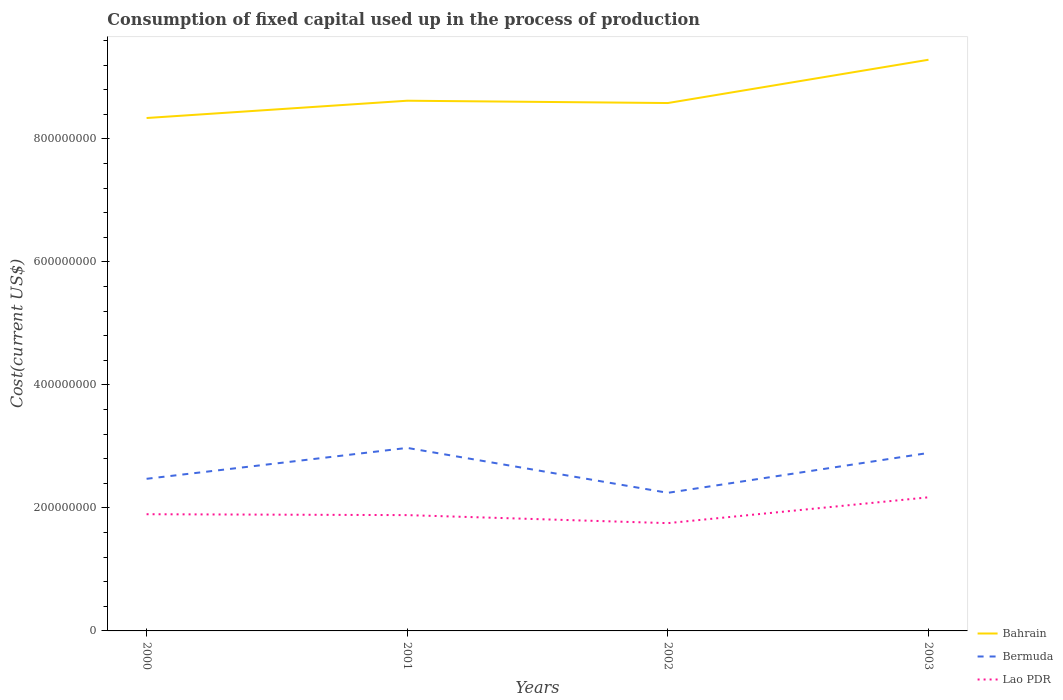Does the line corresponding to Bermuda intersect with the line corresponding to Bahrain?
Your answer should be very brief. No. Across all years, what is the maximum amount consumed in the process of production in Lao PDR?
Your response must be concise. 1.75e+08. In which year was the amount consumed in the process of production in Bahrain maximum?
Offer a terse response. 2000. What is the total amount consumed in the process of production in Bahrain in the graph?
Offer a terse response. -2.81e+07. What is the difference between the highest and the second highest amount consumed in the process of production in Bermuda?
Your answer should be compact. 7.31e+07. What is the difference between the highest and the lowest amount consumed in the process of production in Lao PDR?
Give a very brief answer. 1. How many legend labels are there?
Your answer should be very brief. 3. What is the title of the graph?
Offer a terse response. Consumption of fixed capital used up in the process of production. Does "Fiji" appear as one of the legend labels in the graph?
Make the answer very short. No. What is the label or title of the Y-axis?
Ensure brevity in your answer.  Cost(current US$). What is the Cost(current US$) in Bahrain in 2000?
Provide a succinct answer. 8.34e+08. What is the Cost(current US$) in Bermuda in 2000?
Your answer should be very brief. 2.47e+08. What is the Cost(current US$) of Lao PDR in 2000?
Offer a terse response. 1.90e+08. What is the Cost(current US$) in Bahrain in 2001?
Offer a very short reply. 8.62e+08. What is the Cost(current US$) of Bermuda in 2001?
Your answer should be compact. 2.98e+08. What is the Cost(current US$) of Lao PDR in 2001?
Ensure brevity in your answer.  1.88e+08. What is the Cost(current US$) of Bahrain in 2002?
Offer a terse response. 8.58e+08. What is the Cost(current US$) in Bermuda in 2002?
Your response must be concise. 2.25e+08. What is the Cost(current US$) of Lao PDR in 2002?
Ensure brevity in your answer.  1.75e+08. What is the Cost(current US$) in Bahrain in 2003?
Offer a terse response. 9.29e+08. What is the Cost(current US$) in Bermuda in 2003?
Provide a short and direct response. 2.89e+08. What is the Cost(current US$) in Lao PDR in 2003?
Provide a short and direct response. 2.17e+08. Across all years, what is the maximum Cost(current US$) in Bahrain?
Give a very brief answer. 9.29e+08. Across all years, what is the maximum Cost(current US$) of Bermuda?
Offer a terse response. 2.98e+08. Across all years, what is the maximum Cost(current US$) in Lao PDR?
Provide a succinct answer. 2.17e+08. Across all years, what is the minimum Cost(current US$) of Bahrain?
Ensure brevity in your answer.  8.34e+08. Across all years, what is the minimum Cost(current US$) in Bermuda?
Provide a short and direct response. 2.25e+08. Across all years, what is the minimum Cost(current US$) of Lao PDR?
Provide a short and direct response. 1.75e+08. What is the total Cost(current US$) of Bahrain in the graph?
Make the answer very short. 3.48e+09. What is the total Cost(current US$) of Bermuda in the graph?
Your answer should be compact. 1.06e+09. What is the total Cost(current US$) in Lao PDR in the graph?
Keep it short and to the point. 7.71e+08. What is the difference between the Cost(current US$) in Bahrain in 2000 and that in 2001?
Provide a succinct answer. -2.81e+07. What is the difference between the Cost(current US$) in Bermuda in 2000 and that in 2001?
Provide a succinct answer. -5.02e+07. What is the difference between the Cost(current US$) in Lao PDR in 2000 and that in 2001?
Make the answer very short. 1.45e+06. What is the difference between the Cost(current US$) in Bahrain in 2000 and that in 2002?
Offer a terse response. -2.44e+07. What is the difference between the Cost(current US$) in Bermuda in 2000 and that in 2002?
Keep it short and to the point. 2.28e+07. What is the difference between the Cost(current US$) in Lao PDR in 2000 and that in 2002?
Provide a short and direct response. 1.45e+07. What is the difference between the Cost(current US$) in Bahrain in 2000 and that in 2003?
Ensure brevity in your answer.  -9.48e+07. What is the difference between the Cost(current US$) in Bermuda in 2000 and that in 2003?
Provide a short and direct response. -4.21e+07. What is the difference between the Cost(current US$) of Lao PDR in 2000 and that in 2003?
Your response must be concise. -2.75e+07. What is the difference between the Cost(current US$) in Bahrain in 2001 and that in 2002?
Provide a succinct answer. 3.76e+06. What is the difference between the Cost(current US$) of Bermuda in 2001 and that in 2002?
Ensure brevity in your answer.  7.31e+07. What is the difference between the Cost(current US$) in Lao PDR in 2001 and that in 2002?
Your answer should be very brief. 1.30e+07. What is the difference between the Cost(current US$) in Bahrain in 2001 and that in 2003?
Provide a short and direct response. -6.66e+07. What is the difference between the Cost(current US$) of Bermuda in 2001 and that in 2003?
Make the answer very short. 8.18e+06. What is the difference between the Cost(current US$) of Lao PDR in 2001 and that in 2003?
Your response must be concise. -2.90e+07. What is the difference between the Cost(current US$) in Bahrain in 2002 and that in 2003?
Provide a short and direct response. -7.04e+07. What is the difference between the Cost(current US$) of Bermuda in 2002 and that in 2003?
Provide a short and direct response. -6.49e+07. What is the difference between the Cost(current US$) of Lao PDR in 2002 and that in 2003?
Provide a succinct answer. -4.20e+07. What is the difference between the Cost(current US$) of Bahrain in 2000 and the Cost(current US$) of Bermuda in 2001?
Offer a terse response. 5.36e+08. What is the difference between the Cost(current US$) of Bahrain in 2000 and the Cost(current US$) of Lao PDR in 2001?
Give a very brief answer. 6.46e+08. What is the difference between the Cost(current US$) in Bermuda in 2000 and the Cost(current US$) in Lao PDR in 2001?
Provide a succinct answer. 5.91e+07. What is the difference between the Cost(current US$) of Bahrain in 2000 and the Cost(current US$) of Bermuda in 2002?
Ensure brevity in your answer.  6.10e+08. What is the difference between the Cost(current US$) in Bahrain in 2000 and the Cost(current US$) in Lao PDR in 2002?
Provide a succinct answer. 6.59e+08. What is the difference between the Cost(current US$) of Bermuda in 2000 and the Cost(current US$) of Lao PDR in 2002?
Keep it short and to the point. 7.21e+07. What is the difference between the Cost(current US$) of Bahrain in 2000 and the Cost(current US$) of Bermuda in 2003?
Keep it short and to the point. 5.45e+08. What is the difference between the Cost(current US$) of Bahrain in 2000 and the Cost(current US$) of Lao PDR in 2003?
Ensure brevity in your answer.  6.17e+08. What is the difference between the Cost(current US$) of Bermuda in 2000 and the Cost(current US$) of Lao PDR in 2003?
Keep it short and to the point. 3.01e+07. What is the difference between the Cost(current US$) of Bahrain in 2001 and the Cost(current US$) of Bermuda in 2002?
Provide a short and direct response. 6.38e+08. What is the difference between the Cost(current US$) in Bahrain in 2001 and the Cost(current US$) in Lao PDR in 2002?
Provide a short and direct response. 6.87e+08. What is the difference between the Cost(current US$) of Bermuda in 2001 and the Cost(current US$) of Lao PDR in 2002?
Make the answer very short. 1.22e+08. What is the difference between the Cost(current US$) of Bahrain in 2001 and the Cost(current US$) of Bermuda in 2003?
Offer a very short reply. 5.73e+08. What is the difference between the Cost(current US$) in Bahrain in 2001 and the Cost(current US$) in Lao PDR in 2003?
Your response must be concise. 6.45e+08. What is the difference between the Cost(current US$) in Bermuda in 2001 and the Cost(current US$) in Lao PDR in 2003?
Your answer should be very brief. 8.03e+07. What is the difference between the Cost(current US$) of Bahrain in 2002 and the Cost(current US$) of Bermuda in 2003?
Make the answer very short. 5.69e+08. What is the difference between the Cost(current US$) in Bahrain in 2002 and the Cost(current US$) in Lao PDR in 2003?
Provide a short and direct response. 6.41e+08. What is the difference between the Cost(current US$) in Bermuda in 2002 and the Cost(current US$) in Lao PDR in 2003?
Make the answer very short. 7.29e+06. What is the average Cost(current US$) in Bahrain per year?
Your answer should be compact. 8.71e+08. What is the average Cost(current US$) of Bermuda per year?
Make the answer very short. 2.65e+08. What is the average Cost(current US$) of Lao PDR per year?
Make the answer very short. 1.93e+08. In the year 2000, what is the difference between the Cost(current US$) of Bahrain and Cost(current US$) of Bermuda?
Offer a terse response. 5.87e+08. In the year 2000, what is the difference between the Cost(current US$) of Bahrain and Cost(current US$) of Lao PDR?
Offer a terse response. 6.44e+08. In the year 2000, what is the difference between the Cost(current US$) in Bermuda and Cost(current US$) in Lao PDR?
Provide a succinct answer. 5.76e+07. In the year 2001, what is the difference between the Cost(current US$) of Bahrain and Cost(current US$) of Bermuda?
Your response must be concise. 5.65e+08. In the year 2001, what is the difference between the Cost(current US$) in Bahrain and Cost(current US$) in Lao PDR?
Make the answer very short. 6.74e+08. In the year 2001, what is the difference between the Cost(current US$) of Bermuda and Cost(current US$) of Lao PDR?
Keep it short and to the point. 1.09e+08. In the year 2002, what is the difference between the Cost(current US$) in Bahrain and Cost(current US$) in Bermuda?
Keep it short and to the point. 6.34e+08. In the year 2002, what is the difference between the Cost(current US$) in Bahrain and Cost(current US$) in Lao PDR?
Offer a terse response. 6.83e+08. In the year 2002, what is the difference between the Cost(current US$) of Bermuda and Cost(current US$) of Lao PDR?
Provide a succinct answer. 4.93e+07. In the year 2003, what is the difference between the Cost(current US$) of Bahrain and Cost(current US$) of Bermuda?
Keep it short and to the point. 6.39e+08. In the year 2003, what is the difference between the Cost(current US$) in Bahrain and Cost(current US$) in Lao PDR?
Offer a very short reply. 7.12e+08. In the year 2003, what is the difference between the Cost(current US$) in Bermuda and Cost(current US$) in Lao PDR?
Provide a short and direct response. 7.22e+07. What is the ratio of the Cost(current US$) in Bahrain in 2000 to that in 2001?
Keep it short and to the point. 0.97. What is the ratio of the Cost(current US$) in Bermuda in 2000 to that in 2001?
Ensure brevity in your answer.  0.83. What is the ratio of the Cost(current US$) in Lao PDR in 2000 to that in 2001?
Your answer should be very brief. 1.01. What is the ratio of the Cost(current US$) in Bahrain in 2000 to that in 2002?
Keep it short and to the point. 0.97. What is the ratio of the Cost(current US$) in Bermuda in 2000 to that in 2002?
Offer a terse response. 1.1. What is the ratio of the Cost(current US$) of Lao PDR in 2000 to that in 2002?
Offer a terse response. 1.08. What is the ratio of the Cost(current US$) in Bahrain in 2000 to that in 2003?
Your answer should be very brief. 0.9. What is the ratio of the Cost(current US$) of Bermuda in 2000 to that in 2003?
Your response must be concise. 0.85. What is the ratio of the Cost(current US$) of Lao PDR in 2000 to that in 2003?
Your response must be concise. 0.87. What is the ratio of the Cost(current US$) in Bahrain in 2001 to that in 2002?
Offer a very short reply. 1. What is the ratio of the Cost(current US$) of Bermuda in 2001 to that in 2002?
Give a very brief answer. 1.33. What is the ratio of the Cost(current US$) of Lao PDR in 2001 to that in 2002?
Your response must be concise. 1.07. What is the ratio of the Cost(current US$) of Bahrain in 2001 to that in 2003?
Offer a terse response. 0.93. What is the ratio of the Cost(current US$) of Bermuda in 2001 to that in 2003?
Provide a succinct answer. 1.03. What is the ratio of the Cost(current US$) of Lao PDR in 2001 to that in 2003?
Offer a terse response. 0.87. What is the ratio of the Cost(current US$) of Bahrain in 2002 to that in 2003?
Your answer should be compact. 0.92. What is the ratio of the Cost(current US$) in Bermuda in 2002 to that in 2003?
Your response must be concise. 0.78. What is the ratio of the Cost(current US$) in Lao PDR in 2002 to that in 2003?
Make the answer very short. 0.81. What is the difference between the highest and the second highest Cost(current US$) of Bahrain?
Your answer should be compact. 6.66e+07. What is the difference between the highest and the second highest Cost(current US$) of Bermuda?
Your answer should be compact. 8.18e+06. What is the difference between the highest and the second highest Cost(current US$) in Lao PDR?
Your response must be concise. 2.75e+07. What is the difference between the highest and the lowest Cost(current US$) in Bahrain?
Your answer should be compact. 9.48e+07. What is the difference between the highest and the lowest Cost(current US$) in Bermuda?
Your answer should be compact. 7.31e+07. What is the difference between the highest and the lowest Cost(current US$) in Lao PDR?
Your response must be concise. 4.20e+07. 